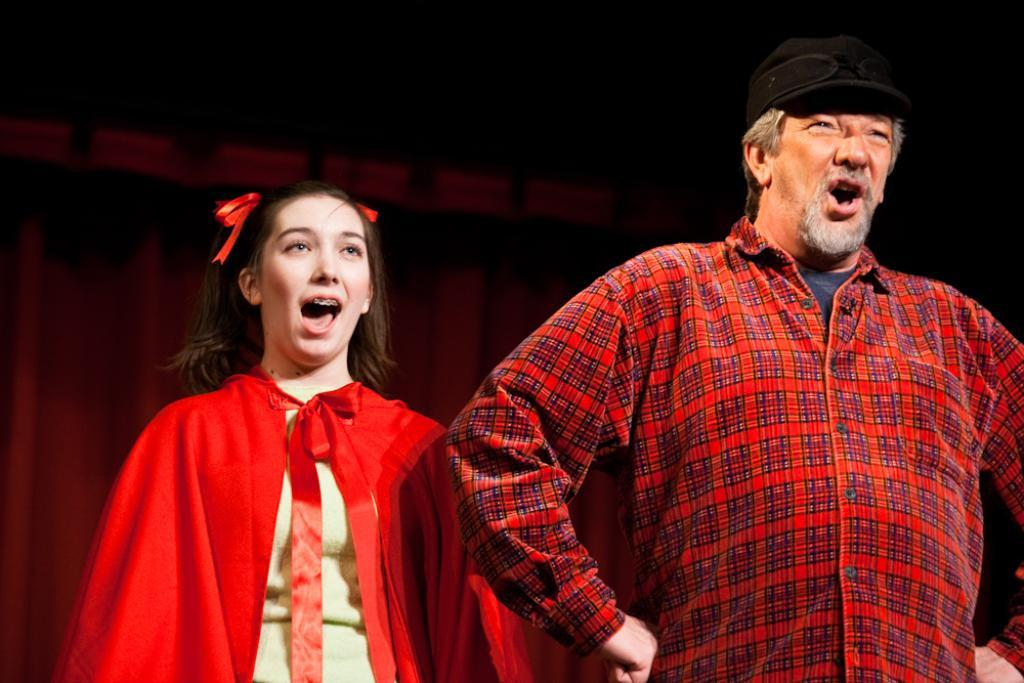How many people are in the image? There are two persons standing in the image. What are the two persons doing? The two persons are singing. Can you describe any background elements in the image? There is a curtain visible in the image. What type of advertisement can be seen on the sock worn by one of the singers? There is no sock or advertisement present in the image. 